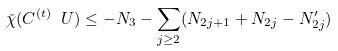Convert formula to latex. <formula><loc_0><loc_0><loc_500><loc_500>\check { \chi } ( C ^ { ( t ) } \ U ) \leq - N _ { 3 } - \sum _ { j \geq 2 } ( N _ { 2 j + 1 } + N _ { 2 j } - N ^ { \prime } _ { 2 j } )</formula> 